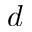Convert formula to latex. <formula><loc_0><loc_0><loc_500><loc_500>d</formula> 